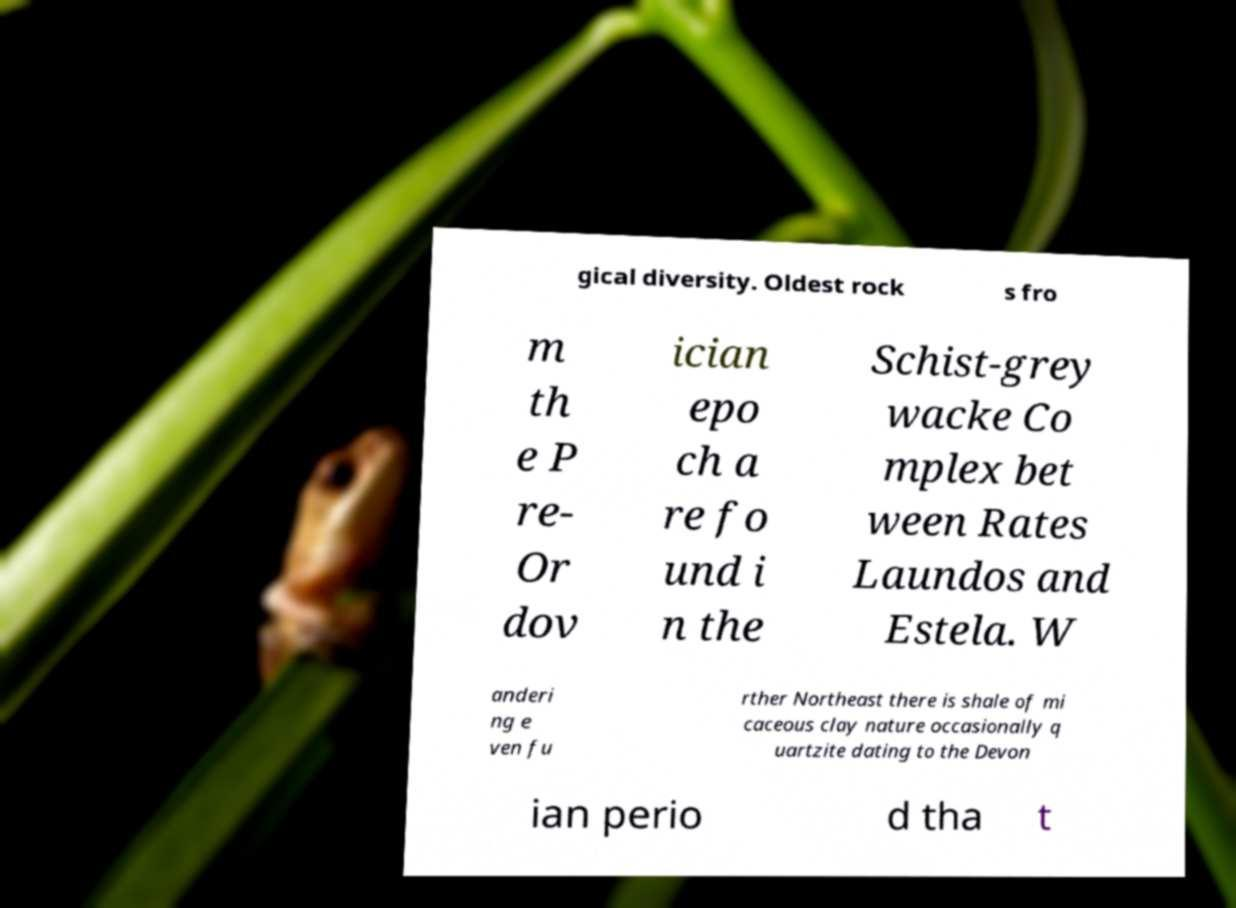Can you accurately transcribe the text from the provided image for me? gical diversity. Oldest rock s fro m th e P re- Or dov ician epo ch a re fo und i n the Schist-grey wacke Co mplex bet ween Rates Laundos and Estela. W anderi ng e ven fu rther Northeast there is shale of mi caceous clay nature occasionally q uartzite dating to the Devon ian perio d tha t 